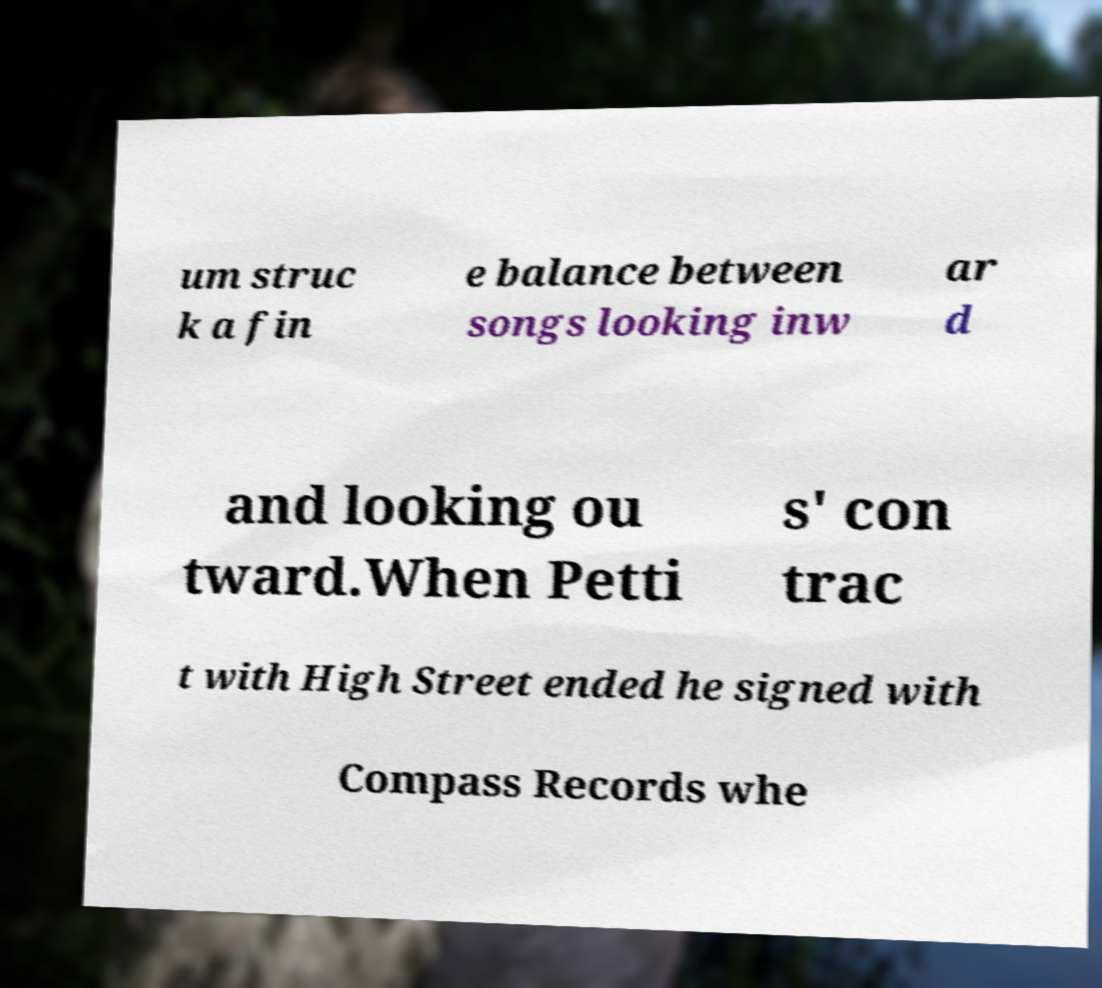Could you extract and type out the text from this image? um struc k a fin e balance between songs looking inw ar d and looking ou tward.When Petti s' con trac t with High Street ended he signed with Compass Records whe 